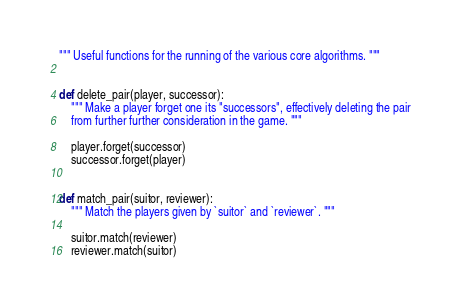<code> <loc_0><loc_0><loc_500><loc_500><_Python_>""" Useful functions for the running of the various core algorithms. """


def delete_pair(player, successor):
    """ Make a player forget one its "successors", effectively deleting the pair
    from further further consideration in the game. """

    player.forget(successor)
    successor.forget(player)


def match_pair(suitor, reviewer):
    """ Match the players given by `suitor` and `reviewer`. """

    suitor.match(reviewer)
    reviewer.match(suitor)
</code> 